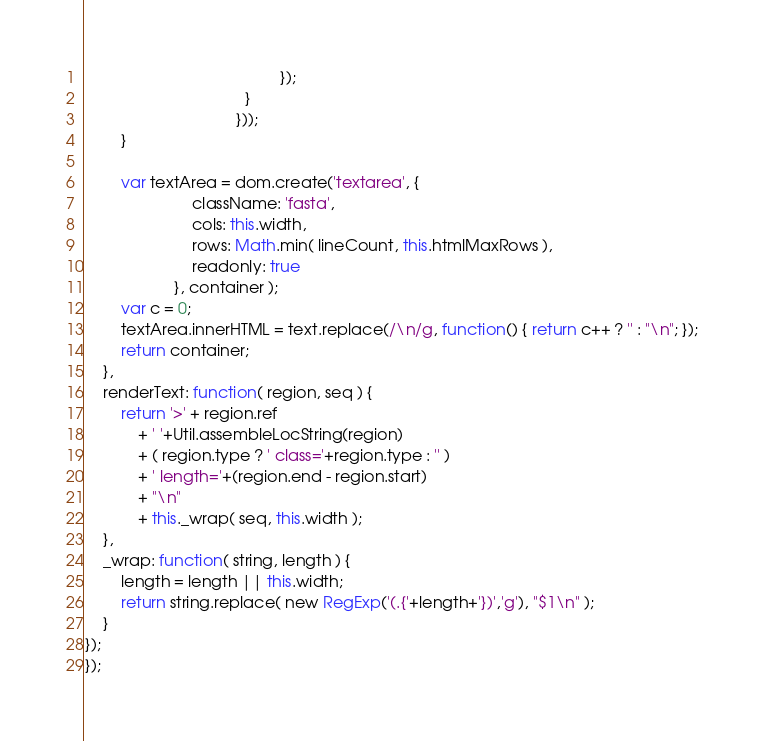Convert code to text. <code><loc_0><loc_0><loc_500><loc_500><_JavaScript_>                                            });
                                    }
                                  }));
        }

        var textArea = dom.create('textarea', {
                        className: 'fasta',
                        cols: this.width,
                        rows: Math.min( lineCount, this.htmlMaxRows ),
                        readonly: true
                    }, container );
        var c = 0;
        textArea.innerHTML = text.replace(/\n/g, function() { return c++ ? '' : "\n"; });
        return container;
    },
    renderText: function( region, seq ) {
        return '>' + region.ref
            + ' '+Util.assembleLocString(region)
            + ( region.type ? ' class='+region.type : '' )
            + ' length='+(region.end - region.start)
            + "\n"
            + this._wrap( seq, this.width );
    },
    _wrap: function( string, length ) {
        length = length || this.width;
        return string.replace( new RegExp('(.{'+length+'})','g'), "$1\n" );
    }
});
});
</code> 